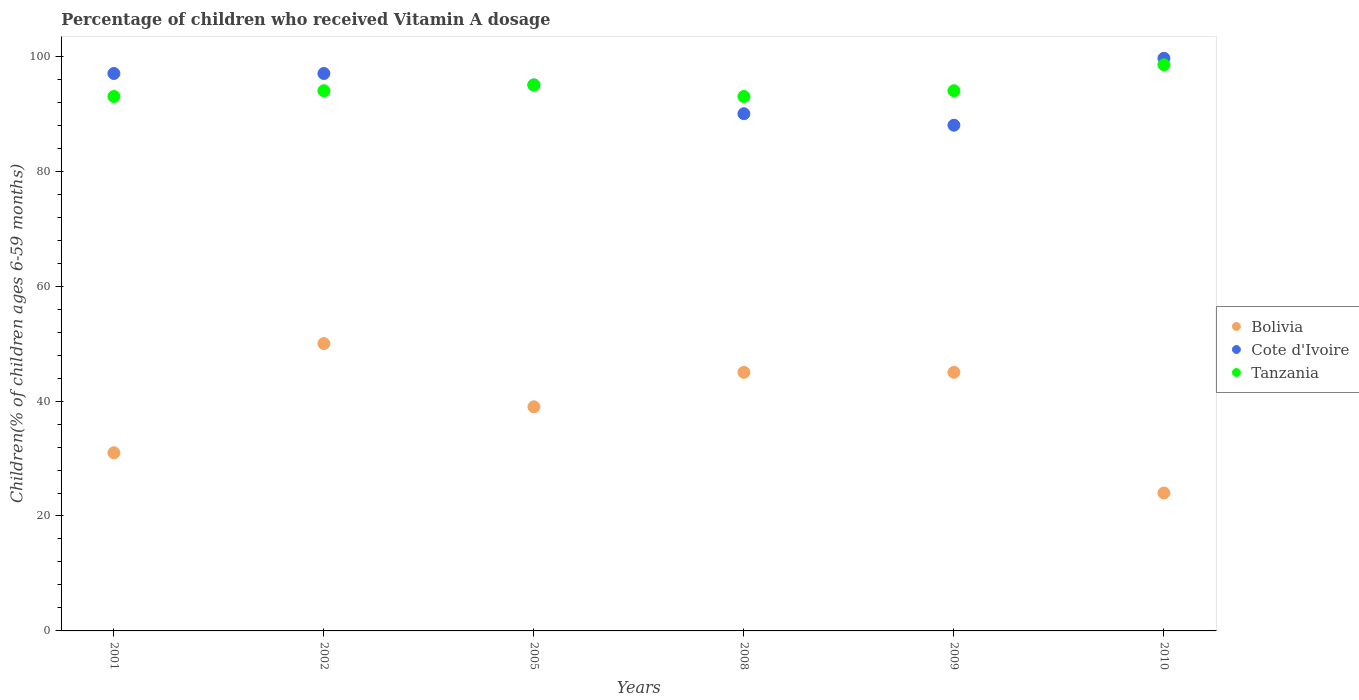How many different coloured dotlines are there?
Ensure brevity in your answer.  3. What is the percentage of children who received Vitamin A dosage in Tanzania in 2008?
Offer a terse response. 93. Across all years, what is the maximum percentage of children who received Vitamin A dosage in Cote d'Ivoire?
Your answer should be compact. 99.64. In which year was the percentage of children who received Vitamin A dosage in Cote d'Ivoire minimum?
Keep it short and to the point. 2009. What is the total percentage of children who received Vitamin A dosage in Bolivia in the graph?
Offer a terse response. 234. What is the difference between the percentage of children who received Vitamin A dosage in Bolivia in 2009 and that in 2010?
Ensure brevity in your answer.  21. What is the average percentage of children who received Vitamin A dosage in Bolivia per year?
Make the answer very short. 39. In the year 2001, what is the difference between the percentage of children who received Vitamin A dosage in Tanzania and percentage of children who received Vitamin A dosage in Cote d'Ivoire?
Offer a terse response. -4. What is the ratio of the percentage of children who received Vitamin A dosage in Cote d'Ivoire in 2005 to that in 2008?
Offer a very short reply. 1.06. What is the difference between the highest and the second highest percentage of children who received Vitamin A dosage in Cote d'Ivoire?
Offer a terse response. 2.64. What is the difference between the highest and the lowest percentage of children who received Vitamin A dosage in Cote d'Ivoire?
Ensure brevity in your answer.  11.64. Is the sum of the percentage of children who received Vitamin A dosage in Cote d'Ivoire in 2002 and 2005 greater than the maximum percentage of children who received Vitamin A dosage in Bolivia across all years?
Offer a terse response. Yes. Is it the case that in every year, the sum of the percentage of children who received Vitamin A dosage in Bolivia and percentage of children who received Vitamin A dosage in Cote d'Ivoire  is greater than the percentage of children who received Vitamin A dosage in Tanzania?
Your answer should be very brief. Yes. Is the percentage of children who received Vitamin A dosage in Tanzania strictly less than the percentage of children who received Vitamin A dosage in Bolivia over the years?
Your answer should be very brief. No. How many dotlines are there?
Your answer should be compact. 3. What is the difference between two consecutive major ticks on the Y-axis?
Ensure brevity in your answer.  20. Are the values on the major ticks of Y-axis written in scientific E-notation?
Ensure brevity in your answer.  No. Does the graph contain any zero values?
Give a very brief answer. No. Does the graph contain grids?
Give a very brief answer. No. What is the title of the graph?
Give a very brief answer. Percentage of children who received Vitamin A dosage. Does "United Arab Emirates" appear as one of the legend labels in the graph?
Your answer should be compact. No. What is the label or title of the Y-axis?
Your response must be concise. Children(% of children ages 6-59 months). What is the Children(% of children ages 6-59 months) in Cote d'Ivoire in 2001?
Keep it short and to the point. 97. What is the Children(% of children ages 6-59 months) of Tanzania in 2001?
Provide a short and direct response. 93. What is the Children(% of children ages 6-59 months) of Bolivia in 2002?
Make the answer very short. 50. What is the Children(% of children ages 6-59 months) of Cote d'Ivoire in 2002?
Your response must be concise. 97. What is the Children(% of children ages 6-59 months) of Tanzania in 2002?
Offer a very short reply. 94. What is the Children(% of children ages 6-59 months) in Cote d'Ivoire in 2005?
Your answer should be compact. 95. What is the Children(% of children ages 6-59 months) in Tanzania in 2008?
Offer a very short reply. 93. What is the Children(% of children ages 6-59 months) in Bolivia in 2009?
Offer a terse response. 45. What is the Children(% of children ages 6-59 months) in Cote d'Ivoire in 2009?
Make the answer very short. 88. What is the Children(% of children ages 6-59 months) of Tanzania in 2009?
Your answer should be compact. 94. What is the Children(% of children ages 6-59 months) in Bolivia in 2010?
Make the answer very short. 24. What is the Children(% of children ages 6-59 months) in Cote d'Ivoire in 2010?
Make the answer very short. 99.64. What is the Children(% of children ages 6-59 months) in Tanzania in 2010?
Give a very brief answer. 98.53. Across all years, what is the maximum Children(% of children ages 6-59 months) in Cote d'Ivoire?
Your response must be concise. 99.64. Across all years, what is the maximum Children(% of children ages 6-59 months) of Tanzania?
Offer a terse response. 98.53. Across all years, what is the minimum Children(% of children ages 6-59 months) of Bolivia?
Ensure brevity in your answer.  24. Across all years, what is the minimum Children(% of children ages 6-59 months) of Cote d'Ivoire?
Ensure brevity in your answer.  88. Across all years, what is the minimum Children(% of children ages 6-59 months) in Tanzania?
Your answer should be very brief. 93. What is the total Children(% of children ages 6-59 months) of Bolivia in the graph?
Give a very brief answer. 234. What is the total Children(% of children ages 6-59 months) in Cote d'Ivoire in the graph?
Your response must be concise. 566.64. What is the total Children(% of children ages 6-59 months) in Tanzania in the graph?
Offer a very short reply. 567.53. What is the difference between the Children(% of children ages 6-59 months) of Bolivia in 2001 and that in 2002?
Your answer should be very brief. -19. What is the difference between the Children(% of children ages 6-59 months) of Cote d'Ivoire in 2001 and that in 2002?
Ensure brevity in your answer.  0. What is the difference between the Children(% of children ages 6-59 months) of Bolivia in 2001 and that in 2008?
Offer a very short reply. -14. What is the difference between the Children(% of children ages 6-59 months) of Cote d'Ivoire in 2001 and that in 2009?
Offer a terse response. 9. What is the difference between the Children(% of children ages 6-59 months) in Bolivia in 2001 and that in 2010?
Keep it short and to the point. 7. What is the difference between the Children(% of children ages 6-59 months) of Cote d'Ivoire in 2001 and that in 2010?
Provide a succinct answer. -2.64. What is the difference between the Children(% of children ages 6-59 months) of Tanzania in 2001 and that in 2010?
Your answer should be compact. -5.53. What is the difference between the Children(% of children ages 6-59 months) of Bolivia in 2002 and that in 2005?
Ensure brevity in your answer.  11. What is the difference between the Children(% of children ages 6-59 months) in Cote d'Ivoire in 2002 and that in 2008?
Ensure brevity in your answer.  7. What is the difference between the Children(% of children ages 6-59 months) of Bolivia in 2002 and that in 2009?
Provide a short and direct response. 5. What is the difference between the Children(% of children ages 6-59 months) in Cote d'Ivoire in 2002 and that in 2009?
Make the answer very short. 9. What is the difference between the Children(% of children ages 6-59 months) in Tanzania in 2002 and that in 2009?
Your answer should be very brief. 0. What is the difference between the Children(% of children ages 6-59 months) of Bolivia in 2002 and that in 2010?
Ensure brevity in your answer.  26. What is the difference between the Children(% of children ages 6-59 months) of Cote d'Ivoire in 2002 and that in 2010?
Provide a succinct answer. -2.64. What is the difference between the Children(% of children ages 6-59 months) of Tanzania in 2002 and that in 2010?
Ensure brevity in your answer.  -4.53. What is the difference between the Children(% of children ages 6-59 months) in Bolivia in 2005 and that in 2008?
Your answer should be compact. -6. What is the difference between the Children(% of children ages 6-59 months) of Cote d'Ivoire in 2005 and that in 2008?
Your response must be concise. 5. What is the difference between the Children(% of children ages 6-59 months) of Bolivia in 2005 and that in 2009?
Your answer should be compact. -6. What is the difference between the Children(% of children ages 6-59 months) of Cote d'Ivoire in 2005 and that in 2009?
Give a very brief answer. 7. What is the difference between the Children(% of children ages 6-59 months) in Tanzania in 2005 and that in 2009?
Give a very brief answer. 1. What is the difference between the Children(% of children ages 6-59 months) in Cote d'Ivoire in 2005 and that in 2010?
Your answer should be very brief. -4.64. What is the difference between the Children(% of children ages 6-59 months) in Tanzania in 2005 and that in 2010?
Offer a terse response. -3.53. What is the difference between the Children(% of children ages 6-59 months) in Tanzania in 2008 and that in 2009?
Provide a succinct answer. -1. What is the difference between the Children(% of children ages 6-59 months) in Cote d'Ivoire in 2008 and that in 2010?
Keep it short and to the point. -9.64. What is the difference between the Children(% of children ages 6-59 months) of Tanzania in 2008 and that in 2010?
Give a very brief answer. -5.53. What is the difference between the Children(% of children ages 6-59 months) of Bolivia in 2009 and that in 2010?
Offer a very short reply. 21. What is the difference between the Children(% of children ages 6-59 months) in Cote d'Ivoire in 2009 and that in 2010?
Keep it short and to the point. -11.64. What is the difference between the Children(% of children ages 6-59 months) in Tanzania in 2009 and that in 2010?
Make the answer very short. -4.53. What is the difference between the Children(% of children ages 6-59 months) in Bolivia in 2001 and the Children(% of children ages 6-59 months) in Cote d'Ivoire in 2002?
Your answer should be compact. -66. What is the difference between the Children(% of children ages 6-59 months) of Bolivia in 2001 and the Children(% of children ages 6-59 months) of Tanzania in 2002?
Your response must be concise. -63. What is the difference between the Children(% of children ages 6-59 months) in Bolivia in 2001 and the Children(% of children ages 6-59 months) in Cote d'Ivoire in 2005?
Your answer should be very brief. -64. What is the difference between the Children(% of children ages 6-59 months) in Bolivia in 2001 and the Children(% of children ages 6-59 months) in Tanzania in 2005?
Your answer should be very brief. -64. What is the difference between the Children(% of children ages 6-59 months) in Cote d'Ivoire in 2001 and the Children(% of children ages 6-59 months) in Tanzania in 2005?
Provide a succinct answer. 2. What is the difference between the Children(% of children ages 6-59 months) in Bolivia in 2001 and the Children(% of children ages 6-59 months) in Cote d'Ivoire in 2008?
Offer a very short reply. -59. What is the difference between the Children(% of children ages 6-59 months) of Bolivia in 2001 and the Children(% of children ages 6-59 months) of Tanzania in 2008?
Provide a succinct answer. -62. What is the difference between the Children(% of children ages 6-59 months) of Cote d'Ivoire in 2001 and the Children(% of children ages 6-59 months) of Tanzania in 2008?
Keep it short and to the point. 4. What is the difference between the Children(% of children ages 6-59 months) of Bolivia in 2001 and the Children(% of children ages 6-59 months) of Cote d'Ivoire in 2009?
Offer a very short reply. -57. What is the difference between the Children(% of children ages 6-59 months) of Bolivia in 2001 and the Children(% of children ages 6-59 months) of Tanzania in 2009?
Your answer should be compact. -63. What is the difference between the Children(% of children ages 6-59 months) of Bolivia in 2001 and the Children(% of children ages 6-59 months) of Cote d'Ivoire in 2010?
Your answer should be compact. -68.64. What is the difference between the Children(% of children ages 6-59 months) in Bolivia in 2001 and the Children(% of children ages 6-59 months) in Tanzania in 2010?
Your answer should be very brief. -67.53. What is the difference between the Children(% of children ages 6-59 months) of Cote d'Ivoire in 2001 and the Children(% of children ages 6-59 months) of Tanzania in 2010?
Your response must be concise. -1.53. What is the difference between the Children(% of children ages 6-59 months) of Bolivia in 2002 and the Children(% of children ages 6-59 months) of Cote d'Ivoire in 2005?
Keep it short and to the point. -45. What is the difference between the Children(% of children ages 6-59 months) of Bolivia in 2002 and the Children(% of children ages 6-59 months) of Tanzania in 2005?
Ensure brevity in your answer.  -45. What is the difference between the Children(% of children ages 6-59 months) of Cote d'Ivoire in 2002 and the Children(% of children ages 6-59 months) of Tanzania in 2005?
Give a very brief answer. 2. What is the difference between the Children(% of children ages 6-59 months) of Bolivia in 2002 and the Children(% of children ages 6-59 months) of Tanzania in 2008?
Provide a succinct answer. -43. What is the difference between the Children(% of children ages 6-59 months) in Bolivia in 2002 and the Children(% of children ages 6-59 months) in Cote d'Ivoire in 2009?
Your answer should be very brief. -38. What is the difference between the Children(% of children ages 6-59 months) of Bolivia in 2002 and the Children(% of children ages 6-59 months) of Tanzania in 2009?
Offer a terse response. -44. What is the difference between the Children(% of children ages 6-59 months) in Bolivia in 2002 and the Children(% of children ages 6-59 months) in Cote d'Ivoire in 2010?
Ensure brevity in your answer.  -49.64. What is the difference between the Children(% of children ages 6-59 months) of Bolivia in 2002 and the Children(% of children ages 6-59 months) of Tanzania in 2010?
Offer a very short reply. -48.53. What is the difference between the Children(% of children ages 6-59 months) of Cote d'Ivoire in 2002 and the Children(% of children ages 6-59 months) of Tanzania in 2010?
Your answer should be very brief. -1.53. What is the difference between the Children(% of children ages 6-59 months) in Bolivia in 2005 and the Children(% of children ages 6-59 months) in Cote d'Ivoire in 2008?
Offer a terse response. -51. What is the difference between the Children(% of children ages 6-59 months) in Bolivia in 2005 and the Children(% of children ages 6-59 months) in Tanzania in 2008?
Ensure brevity in your answer.  -54. What is the difference between the Children(% of children ages 6-59 months) in Bolivia in 2005 and the Children(% of children ages 6-59 months) in Cote d'Ivoire in 2009?
Make the answer very short. -49. What is the difference between the Children(% of children ages 6-59 months) in Bolivia in 2005 and the Children(% of children ages 6-59 months) in Tanzania in 2009?
Ensure brevity in your answer.  -55. What is the difference between the Children(% of children ages 6-59 months) of Bolivia in 2005 and the Children(% of children ages 6-59 months) of Cote d'Ivoire in 2010?
Make the answer very short. -60.64. What is the difference between the Children(% of children ages 6-59 months) of Bolivia in 2005 and the Children(% of children ages 6-59 months) of Tanzania in 2010?
Offer a very short reply. -59.53. What is the difference between the Children(% of children ages 6-59 months) of Cote d'Ivoire in 2005 and the Children(% of children ages 6-59 months) of Tanzania in 2010?
Provide a succinct answer. -3.53. What is the difference between the Children(% of children ages 6-59 months) in Bolivia in 2008 and the Children(% of children ages 6-59 months) in Cote d'Ivoire in 2009?
Keep it short and to the point. -43. What is the difference between the Children(% of children ages 6-59 months) of Bolivia in 2008 and the Children(% of children ages 6-59 months) of Tanzania in 2009?
Ensure brevity in your answer.  -49. What is the difference between the Children(% of children ages 6-59 months) of Cote d'Ivoire in 2008 and the Children(% of children ages 6-59 months) of Tanzania in 2009?
Provide a succinct answer. -4. What is the difference between the Children(% of children ages 6-59 months) in Bolivia in 2008 and the Children(% of children ages 6-59 months) in Cote d'Ivoire in 2010?
Offer a terse response. -54.64. What is the difference between the Children(% of children ages 6-59 months) of Bolivia in 2008 and the Children(% of children ages 6-59 months) of Tanzania in 2010?
Give a very brief answer. -53.53. What is the difference between the Children(% of children ages 6-59 months) of Cote d'Ivoire in 2008 and the Children(% of children ages 6-59 months) of Tanzania in 2010?
Your answer should be compact. -8.53. What is the difference between the Children(% of children ages 6-59 months) of Bolivia in 2009 and the Children(% of children ages 6-59 months) of Cote d'Ivoire in 2010?
Give a very brief answer. -54.64. What is the difference between the Children(% of children ages 6-59 months) of Bolivia in 2009 and the Children(% of children ages 6-59 months) of Tanzania in 2010?
Make the answer very short. -53.53. What is the difference between the Children(% of children ages 6-59 months) of Cote d'Ivoire in 2009 and the Children(% of children ages 6-59 months) of Tanzania in 2010?
Provide a short and direct response. -10.53. What is the average Children(% of children ages 6-59 months) of Bolivia per year?
Your response must be concise. 39. What is the average Children(% of children ages 6-59 months) of Cote d'Ivoire per year?
Make the answer very short. 94.44. What is the average Children(% of children ages 6-59 months) of Tanzania per year?
Offer a very short reply. 94.59. In the year 2001, what is the difference between the Children(% of children ages 6-59 months) in Bolivia and Children(% of children ages 6-59 months) in Cote d'Ivoire?
Provide a succinct answer. -66. In the year 2001, what is the difference between the Children(% of children ages 6-59 months) of Bolivia and Children(% of children ages 6-59 months) of Tanzania?
Offer a terse response. -62. In the year 2001, what is the difference between the Children(% of children ages 6-59 months) in Cote d'Ivoire and Children(% of children ages 6-59 months) in Tanzania?
Your answer should be compact. 4. In the year 2002, what is the difference between the Children(% of children ages 6-59 months) in Bolivia and Children(% of children ages 6-59 months) in Cote d'Ivoire?
Offer a terse response. -47. In the year 2002, what is the difference between the Children(% of children ages 6-59 months) of Bolivia and Children(% of children ages 6-59 months) of Tanzania?
Make the answer very short. -44. In the year 2002, what is the difference between the Children(% of children ages 6-59 months) of Cote d'Ivoire and Children(% of children ages 6-59 months) of Tanzania?
Give a very brief answer. 3. In the year 2005, what is the difference between the Children(% of children ages 6-59 months) of Bolivia and Children(% of children ages 6-59 months) of Cote d'Ivoire?
Your response must be concise. -56. In the year 2005, what is the difference between the Children(% of children ages 6-59 months) of Bolivia and Children(% of children ages 6-59 months) of Tanzania?
Your response must be concise. -56. In the year 2008, what is the difference between the Children(% of children ages 6-59 months) of Bolivia and Children(% of children ages 6-59 months) of Cote d'Ivoire?
Offer a very short reply. -45. In the year 2008, what is the difference between the Children(% of children ages 6-59 months) in Bolivia and Children(% of children ages 6-59 months) in Tanzania?
Offer a terse response. -48. In the year 2008, what is the difference between the Children(% of children ages 6-59 months) in Cote d'Ivoire and Children(% of children ages 6-59 months) in Tanzania?
Offer a terse response. -3. In the year 2009, what is the difference between the Children(% of children ages 6-59 months) in Bolivia and Children(% of children ages 6-59 months) in Cote d'Ivoire?
Your answer should be compact. -43. In the year 2009, what is the difference between the Children(% of children ages 6-59 months) of Bolivia and Children(% of children ages 6-59 months) of Tanzania?
Provide a succinct answer. -49. In the year 2009, what is the difference between the Children(% of children ages 6-59 months) of Cote d'Ivoire and Children(% of children ages 6-59 months) of Tanzania?
Offer a terse response. -6. In the year 2010, what is the difference between the Children(% of children ages 6-59 months) of Bolivia and Children(% of children ages 6-59 months) of Cote d'Ivoire?
Give a very brief answer. -75.64. In the year 2010, what is the difference between the Children(% of children ages 6-59 months) in Bolivia and Children(% of children ages 6-59 months) in Tanzania?
Offer a terse response. -74.53. In the year 2010, what is the difference between the Children(% of children ages 6-59 months) of Cote d'Ivoire and Children(% of children ages 6-59 months) of Tanzania?
Offer a terse response. 1.12. What is the ratio of the Children(% of children ages 6-59 months) of Bolivia in 2001 to that in 2002?
Ensure brevity in your answer.  0.62. What is the ratio of the Children(% of children ages 6-59 months) in Cote d'Ivoire in 2001 to that in 2002?
Your response must be concise. 1. What is the ratio of the Children(% of children ages 6-59 months) of Tanzania in 2001 to that in 2002?
Ensure brevity in your answer.  0.99. What is the ratio of the Children(% of children ages 6-59 months) in Bolivia in 2001 to that in 2005?
Keep it short and to the point. 0.79. What is the ratio of the Children(% of children ages 6-59 months) of Cote d'Ivoire in 2001 to that in 2005?
Provide a short and direct response. 1.02. What is the ratio of the Children(% of children ages 6-59 months) in Tanzania in 2001 to that in 2005?
Ensure brevity in your answer.  0.98. What is the ratio of the Children(% of children ages 6-59 months) in Bolivia in 2001 to that in 2008?
Your answer should be very brief. 0.69. What is the ratio of the Children(% of children ages 6-59 months) of Cote d'Ivoire in 2001 to that in 2008?
Your answer should be compact. 1.08. What is the ratio of the Children(% of children ages 6-59 months) in Bolivia in 2001 to that in 2009?
Your answer should be compact. 0.69. What is the ratio of the Children(% of children ages 6-59 months) of Cote d'Ivoire in 2001 to that in 2009?
Provide a succinct answer. 1.1. What is the ratio of the Children(% of children ages 6-59 months) of Bolivia in 2001 to that in 2010?
Your answer should be compact. 1.29. What is the ratio of the Children(% of children ages 6-59 months) of Cote d'Ivoire in 2001 to that in 2010?
Keep it short and to the point. 0.97. What is the ratio of the Children(% of children ages 6-59 months) in Tanzania in 2001 to that in 2010?
Ensure brevity in your answer.  0.94. What is the ratio of the Children(% of children ages 6-59 months) of Bolivia in 2002 to that in 2005?
Your answer should be compact. 1.28. What is the ratio of the Children(% of children ages 6-59 months) in Cote d'Ivoire in 2002 to that in 2005?
Your answer should be very brief. 1.02. What is the ratio of the Children(% of children ages 6-59 months) in Tanzania in 2002 to that in 2005?
Give a very brief answer. 0.99. What is the ratio of the Children(% of children ages 6-59 months) of Cote d'Ivoire in 2002 to that in 2008?
Keep it short and to the point. 1.08. What is the ratio of the Children(% of children ages 6-59 months) of Tanzania in 2002 to that in 2008?
Make the answer very short. 1.01. What is the ratio of the Children(% of children ages 6-59 months) in Cote d'Ivoire in 2002 to that in 2009?
Ensure brevity in your answer.  1.1. What is the ratio of the Children(% of children ages 6-59 months) of Tanzania in 2002 to that in 2009?
Keep it short and to the point. 1. What is the ratio of the Children(% of children ages 6-59 months) of Bolivia in 2002 to that in 2010?
Ensure brevity in your answer.  2.08. What is the ratio of the Children(% of children ages 6-59 months) in Cote d'Ivoire in 2002 to that in 2010?
Offer a very short reply. 0.97. What is the ratio of the Children(% of children ages 6-59 months) of Tanzania in 2002 to that in 2010?
Your response must be concise. 0.95. What is the ratio of the Children(% of children ages 6-59 months) in Bolivia in 2005 to that in 2008?
Your response must be concise. 0.87. What is the ratio of the Children(% of children ages 6-59 months) of Cote d'Ivoire in 2005 to that in 2008?
Keep it short and to the point. 1.06. What is the ratio of the Children(% of children ages 6-59 months) of Tanzania in 2005 to that in 2008?
Offer a terse response. 1.02. What is the ratio of the Children(% of children ages 6-59 months) of Bolivia in 2005 to that in 2009?
Provide a succinct answer. 0.87. What is the ratio of the Children(% of children ages 6-59 months) in Cote d'Ivoire in 2005 to that in 2009?
Your answer should be very brief. 1.08. What is the ratio of the Children(% of children ages 6-59 months) of Tanzania in 2005 to that in 2009?
Your response must be concise. 1.01. What is the ratio of the Children(% of children ages 6-59 months) of Bolivia in 2005 to that in 2010?
Offer a terse response. 1.62. What is the ratio of the Children(% of children ages 6-59 months) of Cote d'Ivoire in 2005 to that in 2010?
Your answer should be compact. 0.95. What is the ratio of the Children(% of children ages 6-59 months) in Tanzania in 2005 to that in 2010?
Keep it short and to the point. 0.96. What is the ratio of the Children(% of children ages 6-59 months) of Bolivia in 2008 to that in 2009?
Your answer should be compact. 1. What is the ratio of the Children(% of children ages 6-59 months) in Cote d'Ivoire in 2008 to that in 2009?
Provide a succinct answer. 1.02. What is the ratio of the Children(% of children ages 6-59 months) of Bolivia in 2008 to that in 2010?
Provide a succinct answer. 1.88. What is the ratio of the Children(% of children ages 6-59 months) in Cote d'Ivoire in 2008 to that in 2010?
Your response must be concise. 0.9. What is the ratio of the Children(% of children ages 6-59 months) in Tanzania in 2008 to that in 2010?
Your answer should be very brief. 0.94. What is the ratio of the Children(% of children ages 6-59 months) in Bolivia in 2009 to that in 2010?
Offer a terse response. 1.88. What is the ratio of the Children(% of children ages 6-59 months) of Cote d'Ivoire in 2009 to that in 2010?
Your answer should be very brief. 0.88. What is the ratio of the Children(% of children ages 6-59 months) in Tanzania in 2009 to that in 2010?
Keep it short and to the point. 0.95. What is the difference between the highest and the second highest Children(% of children ages 6-59 months) of Cote d'Ivoire?
Keep it short and to the point. 2.64. What is the difference between the highest and the second highest Children(% of children ages 6-59 months) of Tanzania?
Provide a succinct answer. 3.53. What is the difference between the highest and the lowest Children(% of children ages 6-59 months) of Bolivia?
Your response must be concise. 26. What is the difference between the highest and the lowest Children(% of children ages 6-59 months) of Cote d'Ivoire?
Your answer should be compact. 11.64. What is the difference between the highest and the lowest Children(% of children ages 6-59 months) of Tanzania?
Make the answer very short. 5.53. 